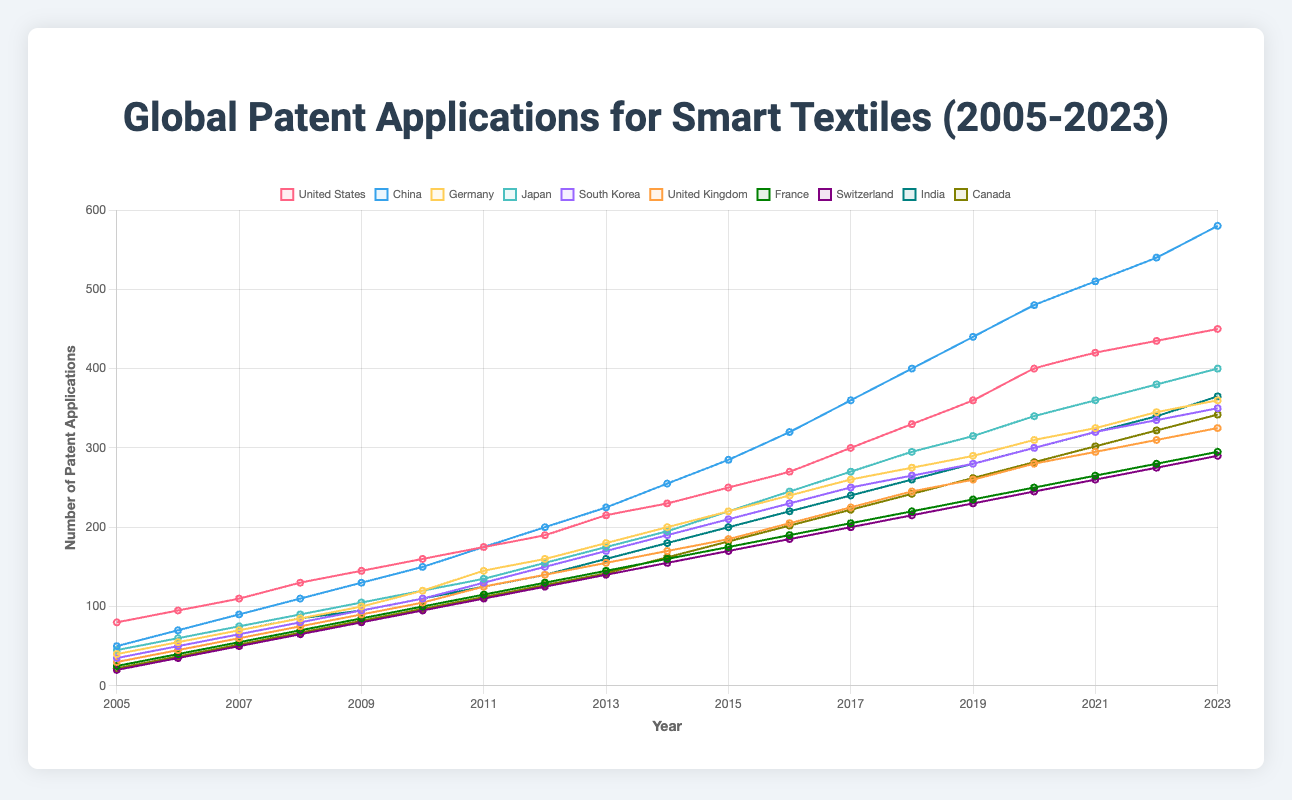What was the trend in patent applications from 2005 to 2023 for the United States? To determine the trend for the United States, observe the line representing the United States from 2005 to 2023. It shows a continuous increase from 80 in 2005 to 450 in 2023.
Answer: Continuous increase Which country had the highest number of patent applications in 2023? Look at the endpoints of each line representing different countries in 2023. China had the highest number of patent applications with 580 in 2023.
Answer: China How did the number of patent applications in China compare to those in the United States in the year 2020? Find the data points for China and the United States in 2020: China had 480 applications and the United States had 400. Therefore, China had more applications than the United States in 2020.
Answer: China had more Which two countries had the closest number of patent applications in 2015? Examine the figures for each country in 2015: Germany and Japan had 220 and 220 patent applications, respectively, indicating they had the closest numbers.
Answer: Germany and Japan What is the difference in the number of patent applications between South Korea and the United Kingdom in 2016? Check the values for South Korea and the United Kingdom in 2016: South Korea had 230 and the United Kingdom had 205. The difference is 230 - 205 = 25.
Answer: 25 Which country has shown the most rapid growth in patent applications between 2005 and 2023? To determine the country with the most rapid growth, calculate the difference in patent applications from 2005 to 2023 for each country. China increased from 50 to 580 (an increase of 530), which is the highest growth compared to other countries.
Answer: China How does the trend in patent applications for Germany contrast from that of Japan from 2005 to 2023? Compare the lines representing Germany and Japan from 2005 to 2023. Both show an upward trend, but Germany's growth is slightly more moderate compared to Japan. Germany increased from 40 to 360, while Japan increased from 45 to 400.
Answer: Japan had faster growth What is the average number of patent applications in the United Kingdom over the years 2010-2015 inclusive? Sum the United Kingdom’s patent applications from 2010 to 2015 (105, 125, 140, 155, 170, 185 = 850) and divide by the number of years (6). So, 850 / 6 = ~141.67.
Answer: ~141.67 